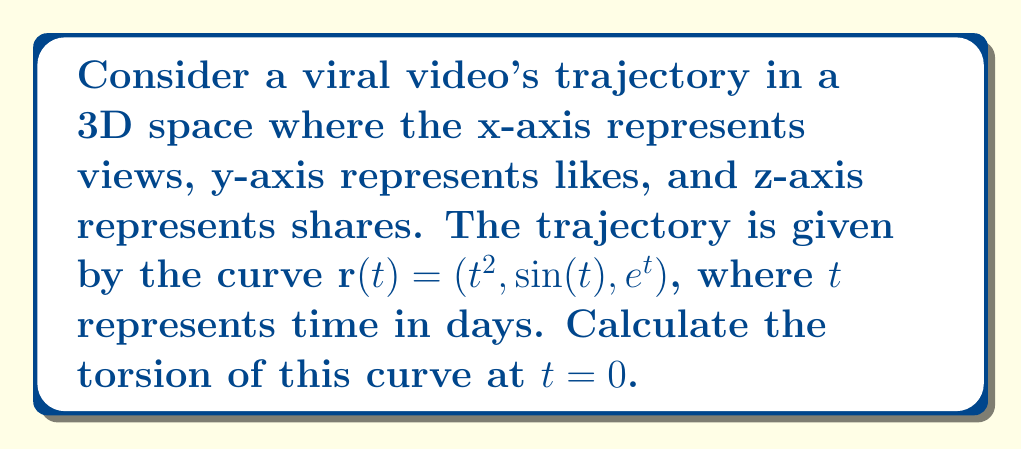Help me with this question. To find the torsion of the curve, we need to follow these steps:

1) First, calculate $\mathbf{r}'(t)$, $\mathbf{r}''(t)$, and $\mathbf{r}'''(t)$:

   $\mathbf{r}'(t) = (2t, \cos(t), e^t)$
   $\mathbf{r}''(t) = (2, -\sin(t), e^t)$
   $\mathbf{r}'''(t) = (0, -\cos(t), e^t)$

2) The torsion $\tau$ is given by the formula:

   $$\tau = \frac{(\mathbf{r}' \times \mathbf{r}'') \cdot \mathbf{r}'''}{|\mathbf{r}' \times \mathbf{r}''|^2}$$

3) Calculate $\mathbf{r}' \times \mathbf{r}''$:

   $\mathbf{r}' \times \mathbf{r}'' = \begin{vmatrix} 
   \mathbf{i} & \mathbf{j} & \mathbf{k} \\
   2t & \cos(t) & e^t \\
   2 & -\sin(t) & e^t
   \end{vmatrix}$

   $= (e^t\cos(t) + e^t\sin(t))\mathbf{i} + (2e^t - 2te^t)\mathbf{j} + (2\sin(t) + 2t\cos(t))\mathbf{k}$

4) Now, calculate $(\mathbf{r}' \times \mathbf{r}'') \cdot \mathbf{r}'''$ at $t=0$:

   $((e^0\cos(0) + e^0\sin(0))\mathbf{i} + (2e^0 - 2\cdot0\cdot e^0)\mathbf{j} + (2\sin(0) + 2\cdot0\cdot\cos(0))\mathbf{k}) \cdot (0, -\cos(0), e^0)$

   $= (1 \cdot 0) + (2 \cdot (-1)) + (0 \cdot 1) = -2$

5) Calculate $|\mathbf{r}' \times \mathbf{r}''|^2$ at $t=0$:

   $((e^0\cos(0) + e^0\sin(0))^2 + (2e^0 - 2\cdot0\cdot e^0)^2 + (2\sin(0) + 2\cdot0\cdot\cos(0))^2$

   $= 1^2 + 2^2 + 0^2 = 5$

6) Therefore, the torsion at $t=0$ is:

   $$\tau = \frac{-2}{5} = -\frac{2}{5}$$
Answer: $-\frac{2}{5}$ 